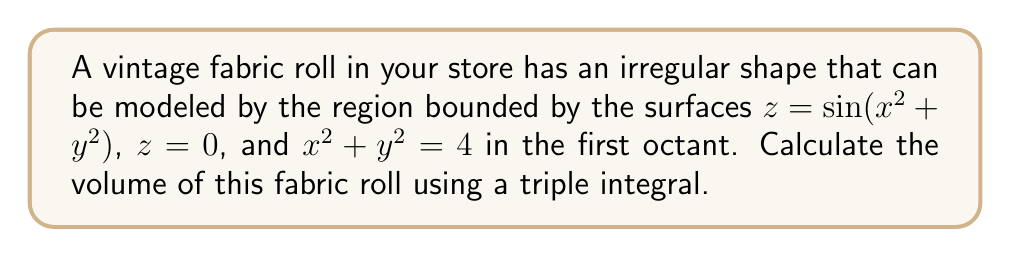Could you help me with this problem? To calculate the volume of the irregularly shaped fabric roll, we need to set up and evaluate a triple integral. Here's the step-by-step process:

1) The region is bounded by $z = \sin(x^2 + y^2)$ from above and $z = 0$ from below, with the circular boundary $x^2 + y^2 = 4$ in the xy-plane.

2) Due to the circular boundary, it's beneficial to use cylindrical coordinates:
   $x = r\cos\theta$, $y = r\sin\theta$, $z = z$

3) The bounds for our integration will be:
   $0 \leq r \leq 2$ (radius from 0 to 2)
   $0 \leq \theta \leq \frac{\pi}{2}$ (first quadrant, so angle from 0 to π/2)
   $0 \leq z \leq \sin(r^2)$ (z from 0 to the upper surface)

4) The volume integral in cylindrical coordinates is:

   $$V = \int_0^{\frac{\pi}{2}} \int_0^2 \int_0^{\sin(r^2)} r \, dz \, dr \, d\theta$$

5) Integrate with respect to z:

   $$V = \int_0^{\frac{\pi}{2}} \int_0^2 r \sin(r^2) \, dr \, d\theta$$

6) Integrate with respect to r:
   Let $u = r^2$, then $du = 2r \, dr$, so $r \, dr = \frac{1}{2} \, du$

   $$V = \int_0^{\frac{\pi}{2}} \left[ -\frac{1}{2}\cos(u) \right]_0^4 \, d\theta$$
   $$= \int_0^{\frac{\pi}{2}} \left[ -\frac{1}{2}\cos(4) + \frac{1}{2} \right] \, d\theta$$

7) Integrate with respect to θ:

   $$V = \left[ -\frac{1}{2}\cos(4) + \frac{1}{2} \right] \cdot \frac{\pi}{2}$$

8) Simplify:

   $$V = \frac{\pi}{4}[1 - \cos(4)]$$
Answer: $\frac{\pi}{4}[1 - \cos(4)]$ cubic units 